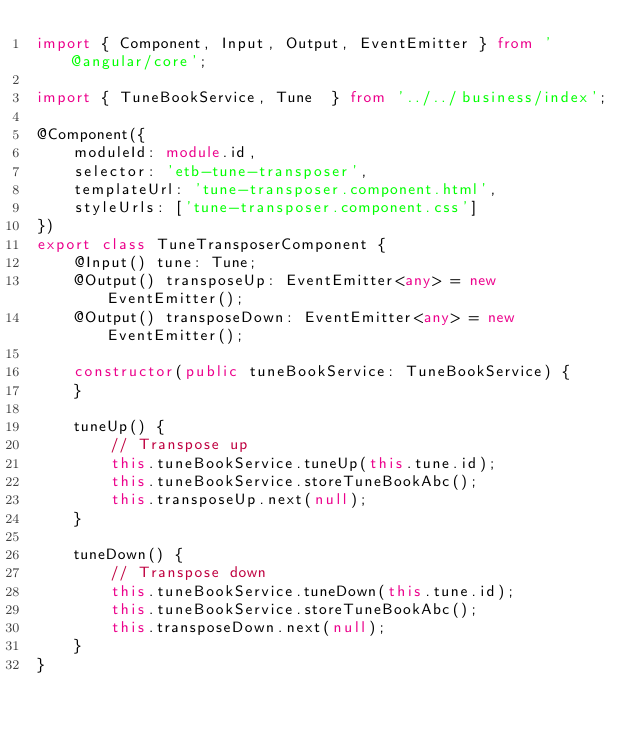Convert code to text. <code><loc_0><loc_0><loc_500><loc_500><_TypeScript_>import { Component, Input, Output, EventEmitter } from '@angular/core';

import { TuneBookService, Tune  } from '../../business/index';

@Component({
    moduleId: module.id,
    selector: 'etb-tune-transposer',
    templateUrl: 'tune-transposer.component.html',
    styleUrls: ['tune-transposer.component.css']
})
export class TuneTransposerComponent {
    @Input() tune: Tune;
    @Output() transposeUp: EventEmitter<any> = new EventEmitter();
    @Output() transposeDown: EventEmitter<any> = new EventEmitter();

    constructor(public tuneBookService: TuneBookService) {
    }

    tuneUp() {
        // Transpose up
        this.tuneBookService.tuneUp(this.tune.id);
        this.tuneBookService.storeTuneBookAbc();
        this.transposeUp.next(null);
    }

    tuneDown() {
        // Transpose down
        this.tuneBookService.tuneDown(this.tune.id);
        this.tuneBookService.storeTuneBookAbc();
        this.transposeDown.next(null);
    }
}
</code> 